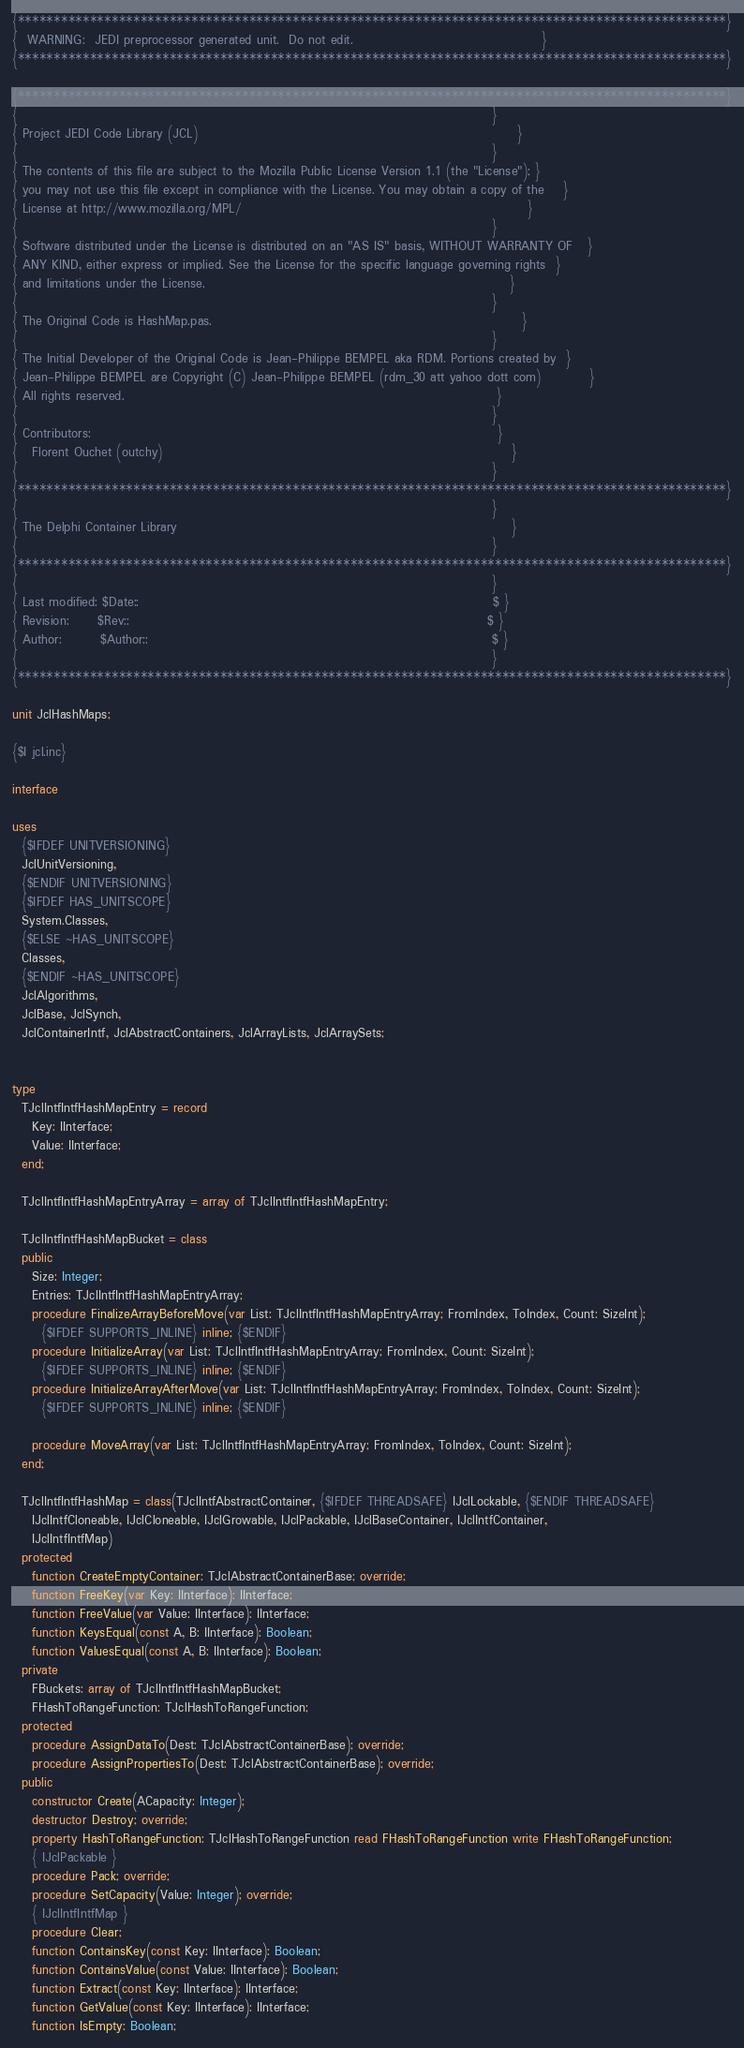<code> <loc_0><loc_0><loc_500><loc_500><_Pascal_>{**************************************************************************************************}
{  WARNING:  JEDI preprocessor generated unit.  Do not edit.                                       }
{**************************************************************************************************}

{**************************************************************************************************}
{                                                                                                  }
{ Project JEDI Code Library (JCL)                                                                  }
{                                                                                                  }
{ The contents of this file are subject to the Mozilla Public License Version 1.1 (the "License"); }
{ you may not use this file except in compliance with the License. You may obtain a copy of the    }
{ License at http://www.mozilla.org/MPL/                                                           }
{                                                                                                  }
{ Software distributed under the License is distributed on an "AS IS" basis, WITHOUT WARRANTY OF   }
{ ANY KIND, either express or implied. See the License for the specific language governing rights  }
{ and limitations under the License.                                                               }
{                                                                                                  }
{ The Original Code is HashMap.pas.                                                                }
{                                                                                                  }
{ The Initial Developer of the Original Code is Jean-Philippe BEMPEL aka RDM. Portions created by  }
{ Jean-Philippe BEMPEL are Copyright (C) Jean-Philippe BEMPEL (rdm_30 att yahoo dott com)          }
{ All rights reserved.                                                                             }
{                                                                                                  }
{ Contributors:                                                                                    }
{   Florent Ouchet (outchy)                                                                        }
{                                                                                                  }
{**************************************************************************************************}
{                                                                                                  }
{ The Delphi Container Library                                                                     }
{                                                                                                  }
{**************************************************************************************************}
{                                                                                                  }
{ Last modified: $Date::                                                                         $ }
{ Revision:      $Rev::                                                                          $ }
{ Author:        $Author::                                                                       $ }
{                                                                                                  }
{**************************************************************************************************}

unit JclHashMaps;

{$I jcl.inc}

interface

uses
  {$IFDEF UNITVERSIONING}
  JclUnitVersioning,
  {$ENDIF UNITVERSIONING}
  {$IFDEF HAS_UNITSCOPE}
  System.Classes,
  {$ELSE ~HAS_UNITSCOPE}
  Classes,
  {$ENDIF ~HAS_UNITSCOPE}
  JclAlgorithms,
  JclBase, JclSynch,
  JclContainerIntf, JclAbstractContainers, JclArrayLists, JclArraySets;


type
  TJclIntfIntfHashMapEntry = record
    Key: IInterface;
    Value: IInterface;
  end;

  TJclIntfIntfHashMapEntryArray = array of TJclIntfIntfHashMapEntry;

  TJclIntfIntfHashMapBucket = class
  public
    Size: Integer;
    Entries: TJclIntfIntfHashMapEntryArray;
    procedure FinalizeArrayBeforeMove(var List: TJclIntfIntfHashMapEntryArray; FromIndex, ToIndex, Count: SizeInt);
      {$IFDEF SUPPORTS_INLINE} inline; {$ENDIF}
    procedure InitializeArray(var List: TJclIntfIntfHashMapEntryArray; FromIndex, Count: SizeInt);
      {$IFDEF SUPPORTS_INLINE} inline; {$ENDIF}
    procedure InitializeArrayAfterMove(var List: TJclIntfIntfHashMapEntryArray; FromIndex, ToIndex, Count: SizeInt);
      {$IFDEF SUPPORTS_INLINE} inline; {$ENDIF}

    procedure MoveArray(var List: TJclIntfIntfHashMapEntryArray; FromIndex, ToIndex, Count: SizeInt);
  end;

  TJclIntfIntfHashMap = class(TJclIntfAbstractContainer, {$IFDEF THREADSAFE} IJclLockable, {$ENDIF THREADSAFE}
    IJclIntfCloneable, IJclCloneable, IJclGrowable, IJclPackable, IJclBaseContainer, IJclIntfContainer,
    IJclIntfIntfMap)
  protected
    function CreateEmptyContainer: TJclAbstractContainerBase; override;
    function FreeKey(var Key: IInterface): IInterface;
    function FreeValue(var Value: IInterface): IInterface;
    function KeysEqual(const A, B: IInterface): Boolean;
    function ValuesEqual(const A, B: IInterface): Boolean;
  private
    FBuckets: array of TJclIntfIntfHashMapBucket;
    FHashToRangeFunction: TJclHashToRangeFunction;
  protected
    procedure AssignDataTo(Dest: TJclAbstractContainerBase); override;
    procedure AssignPropertiesTo(Dest: TJclAbstractContainerBase); override;
  public
    constructor Create(ACapacity: Integer);
    destructor Destroy; override;
    property HashToRangeFunction: TJclHashToRangeFunction read FHashToRangeFunction write FHashToRangeFunction;
    { IJclPackable }
    procedure Pack; override;
    procedure SetCapacity(Value: Integer); override;
    { IJclIntfIntfMap }
    procedure Clear;
    function ContainsKey(const Key: IInterface): Boolean;
    function ContainsValue(const Value: IInterface): Boolean;
    function Extract(const Key: IInterface): IInterface;
    function GetValue(const Key: IInterface): IInterface;
    function IsEmpty: Boolean;</code> 